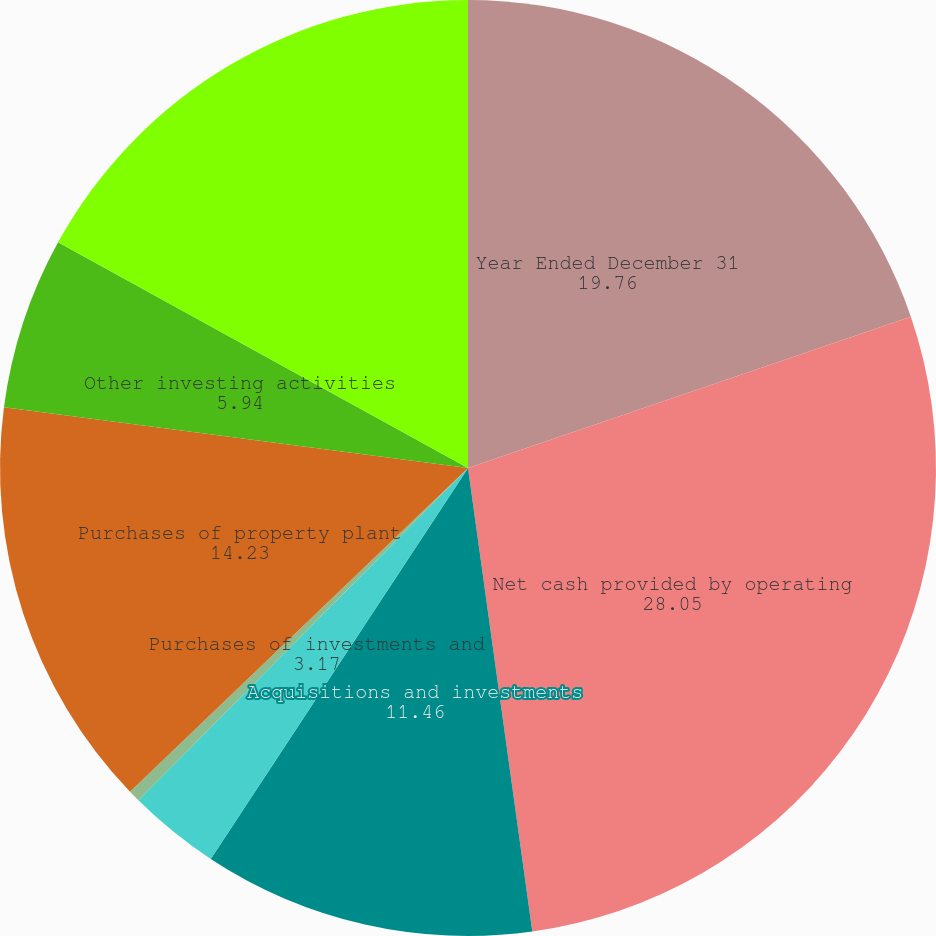Convert chart. <chart><loc_0><loc_0><loc_500><loc_500><pie_chart><fcel>Year Ended December 31<fcel>Net cash provided by operating<fcel>Acquisitions and investments<fcel>Purchases of investments and<fcel>Proceeds from disposals of<fcel>Purchases of property plant<fcel>Other investing activities<fcel>Net cash used in investing<nl><fcel>19.76%<fcel>28.05%<fcel>11.46%<fcel>3.17%<fcel>0.41%<fcel>14.23%<fcel>5.94%<fcel>16.99%<nl></chart> 